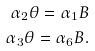<formula> <loc_0><loc_0><loc_500><loc_500>\alpha _ { 2 } \theta = \alpha _ { 1 } B \\ \alpha _ { 3 } \theta = \alpha _ { 6 } B .</formula> 